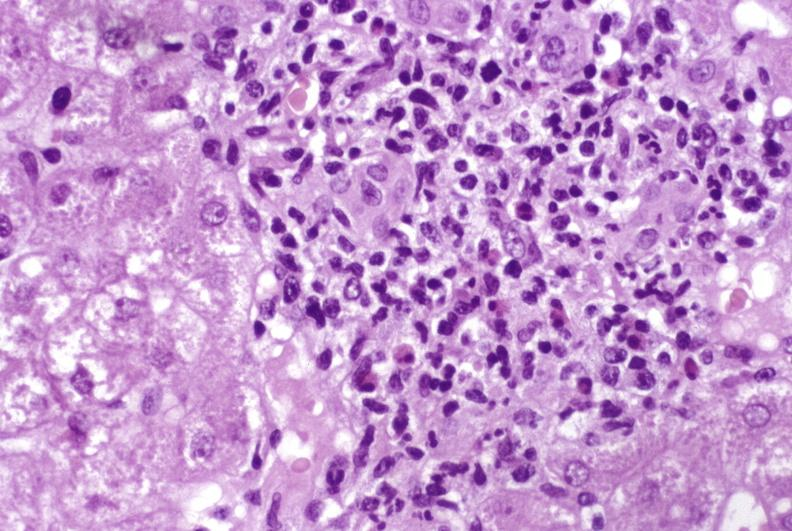s foot present?
Answer the question using a single word or phrase. No 